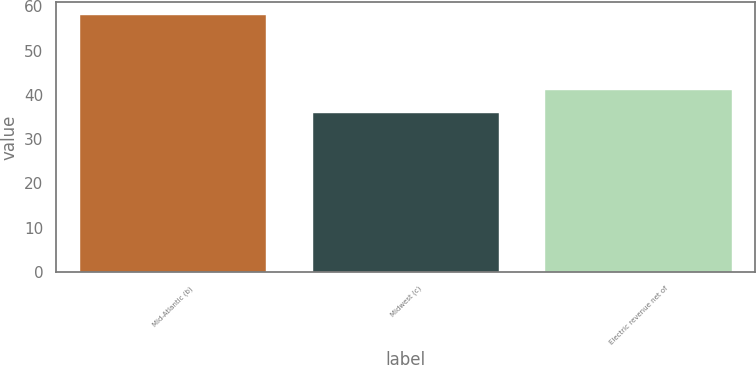Convert chart. <chart><loc_0><loc_0><loc_500><loc_500><bar_chart><fcel>Mid-Atlantic (b)<fcel>Midwest (c)<fcel>Electric revenue net of<nl><fcel>58<fcel>35.99<fcel>41.07<nl></chart> 